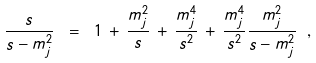Convert formula to latex. <formula><loc_0><loc_0><loc_500><loc_500>\frac { s } { s - m _ { j } ^ { 2 } } \ = \ 1 \, + \, \frac { m _ { j } ^ { 2 } } { s } \, + \, \frac { m _ { j } ^ { 4 } } { s ^ { 2 } } \, + \, \frac { m _ { j } ^ { 4 } } { s ^ { 2 } } \frac { m _ { j } ^ { 2 } } { s - m _ { j } ^ { 2 } } \ ,</formula> 